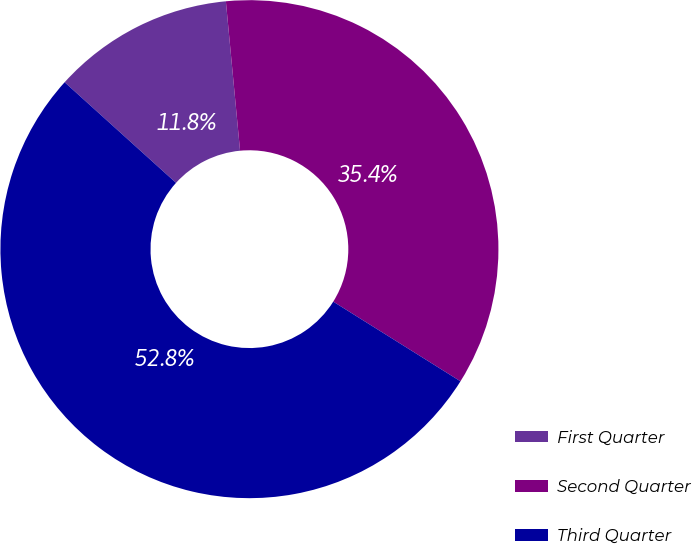<chart> <loc_0><loc_0><loc_500><loc_500><pie_chart><fcel>First Quarter<fcel>Second Quarter<fcel>Third Quarter<nl><fcel>11.8%<fcel>35.41%<fcel>52.79%<nl></chart> 